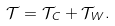Convert formula to latex. <formula><loc_0><loc_0><loc_500><loc_500>\mathcal { T } = \mathcal { T } _ { C } + \mathcal { T } _ { W } .</formula> 